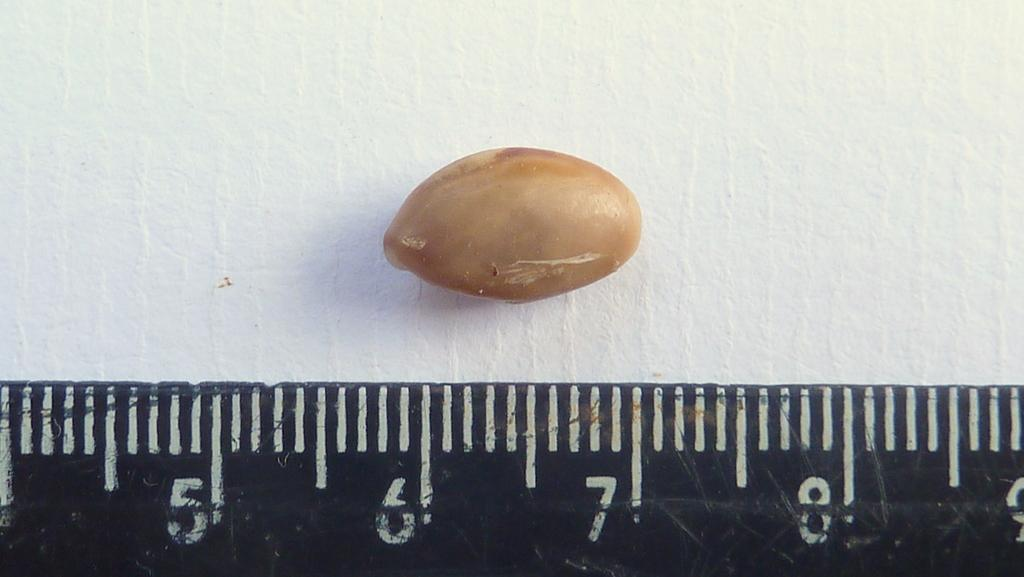<image>
Present a compact description of the photo's key features. Black ruler measuring a peanut with it stopping at the number 7. 